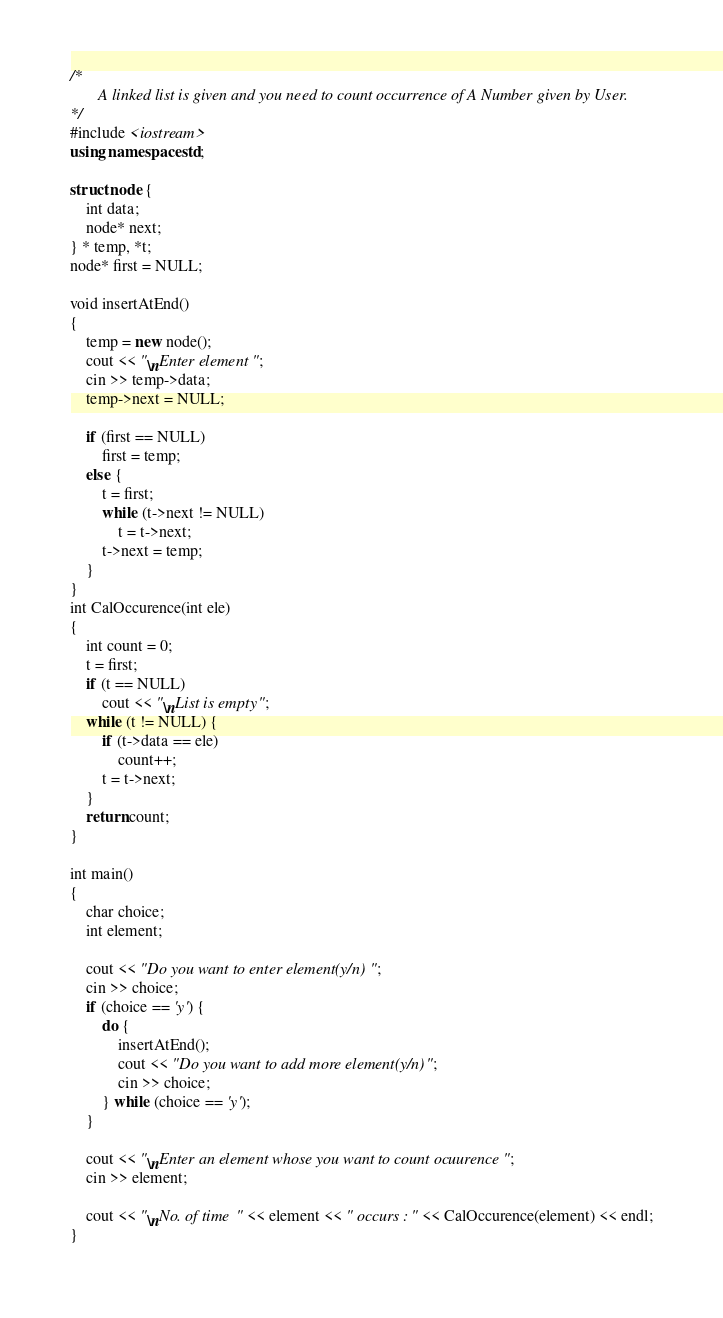<code> <loc_0><loc_0><loc_500><loc_500><_C++_>/*
       A linked list is given and you need to count occurrence of A Number given by User.
*/
#include <iostream>
using namespace std;

struct node {
    int data;
    node* next;
} * temp, *t;
node* first = NULL;

void insertAtEnd()
{
    temp = new node();
    cout << "\nEnter element ";
    cin >> temp->data;
    temp->next = NULL;

    if (first == NULL)
        first = temp;
    else {
        t = first;
        while (t->next != NULL)
            t = t->next;
        t->next = temp;
    }
}
int CalOccurence(int ele)
{
    int count = 0;
    t = first;
    if (t == NULL)
        cout << "\nList is empty";
    while (t != NULL) {
        if (t->data == ele)
            count++;
        t = t->next;
    }
    return count;
}

int main()
{
    char choice;
    int element;

    cout << "Do you want to enter element(y/n) ";
    cin >> choice;
    if (choice == 'y') {
        do {
            insertAtEnd();
            cout << "Do you want to add more element(y/n)";
            cin >> choice;
        } while (choice == 'y');
    }

    cout << "\nEnter an element whose you want to count ocuurence ";
    cin >> element;

    cout << "\nNo. of time " << element << " occurs : " << CalOccurence(element) << endl;
}
</code> 